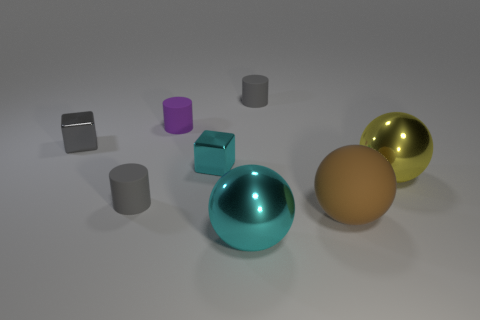The big rubber ball is what color?
Provide a short and direct response. Brown. There is a gray object that is in front of the shiny object that is to the right of the matte ball to the right of the big cyan metal thing; what is it made of?
Offer a terse response. Rubber. There is a cyan ball that is the same material as the cyan cube; what is its size?
Keep it short and to the point. Large. Is there a sphere that has the same color as the large matte thing?
Your response must be concise. No. Is the size of the rubber ball the same as the gray cylinder behind the tiny purple rubber cylinder?
Your answer should be compact. No. There is a tiny cube right of the gray rubber cylinder in front of the purple matte cylinder; what number of brown balls are on the left side of it?
Your answer should be very brief. 0. There is a tiny gray metal block; are there any purple matte cylinders on the left side of it?
Give a very brief answer. No. What is the shape of the gray metallic object?
Your answer should be compact. Cube. The large cyan thing on the right side of the gray cylinder that is left of the tiny gray cylinder that is on the right side of the cyan metallic sphere is what shape?
Provide a short and direct response. Sphere. What number of other objects are there of the same shape as the purple object?
Keep it short and to the point. 2. 